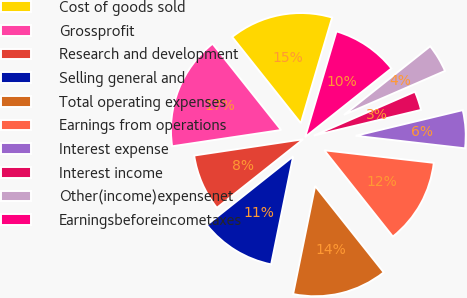Convert chart to OTSL. <chart><loc_0><loc_0><loc_500><loc_500><pie_chart><fcel>Cost of goods sold<fcel>Grossprofit<fcel>Research and development<fcel>Selling general and<fcel>Total operating expenses<fcel>Earnings from operations<fcel>Interest expense<fcel>Interest income<fcel>Other(income)expensenet<fcel>Earningsbeforeincometaxes<nl><fcel>15.28%<fcel>16.67%<fcel>8.33%<fcel>11.11%<fcel>13.89%<fcel>12.5%<fcel>5.56%<fcel>2.78%<fcel>4.17%<fcel>9.72%<nl></chart> 